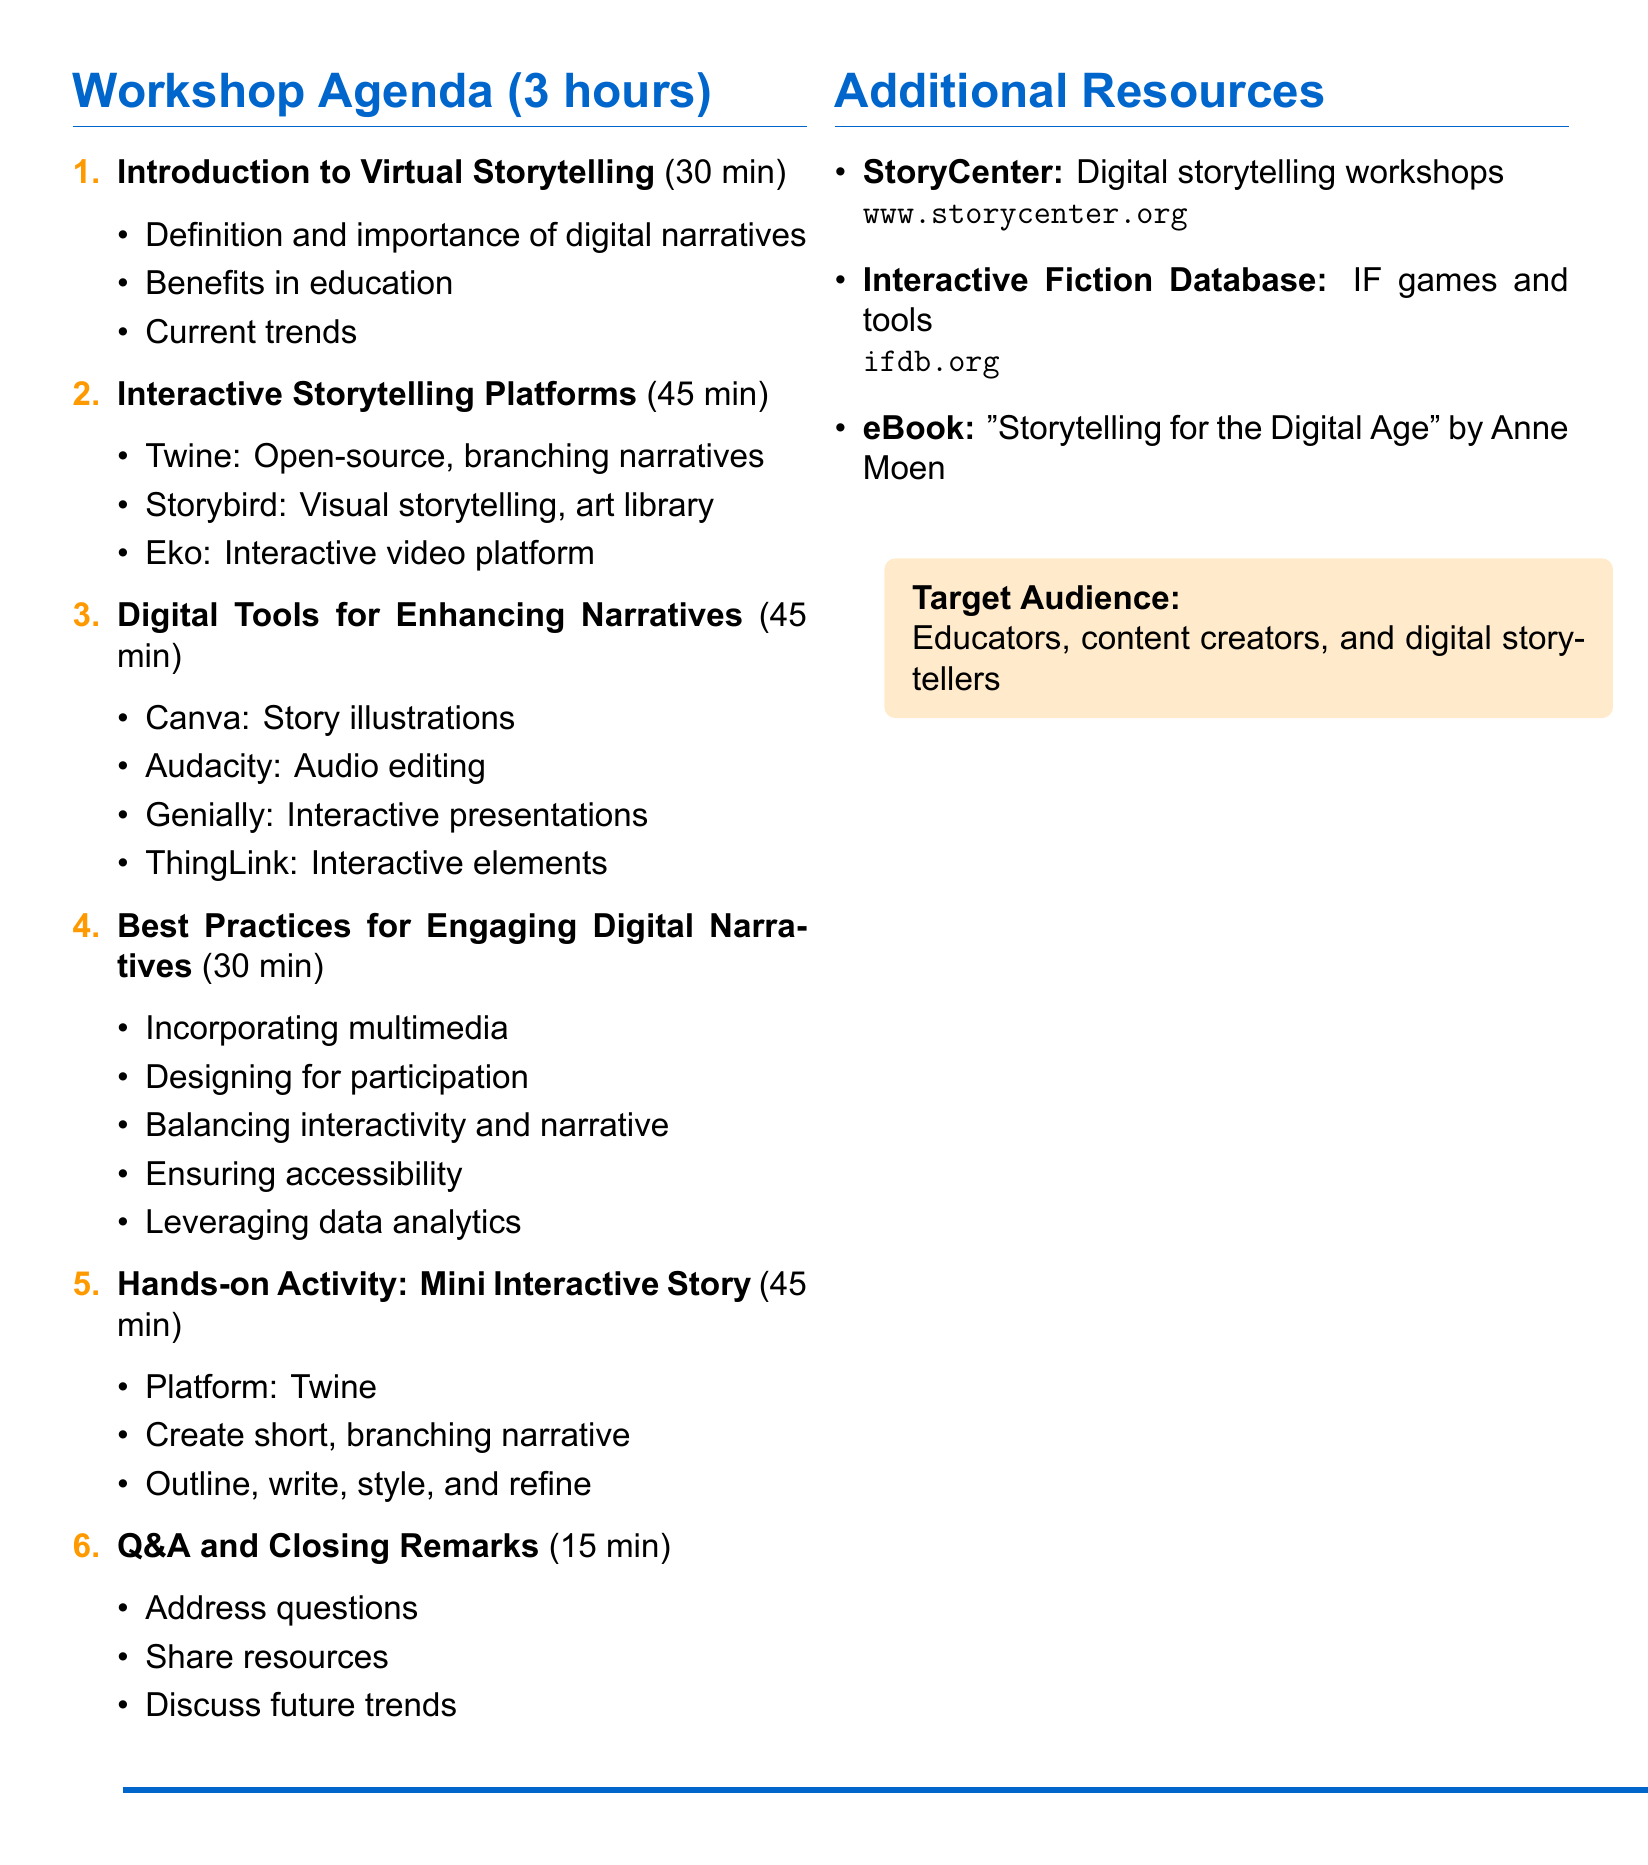What is the title of the workshop? The title of the workshop is explicitly mentioned in the document as "Virtual Storytelling Workshop: Interactive Tools and Platforms for Engaging Digital Narratives."
Answer: Virtual Storytelling Workshop: Interactive Tools and Platforms for Engaging Digital Narratives How long is the workshop? The duration of the workshop is stated as 3 hours in the document.
Answer: 3 hours Who is the target audience for the workshop? The document specifies that the target audience includes educators, content creators, and digital storytellers.
Answer: Educators, content creators, and digital storytellers What platform will be used for the hands-on activity? The hands-on activity section mentions that the platform to be used is Twine.
Answer: Twine What is one key feature of Eko? The document lists key features of Eko; one of them is "Choice-based videos."
Answer: Choice-based videos How many main sections are there in the workshop agenda? There are six main sections outlined in the workshop agenda.
Answer: 6 What is a recommended practice for engaging digital narratives? The document lists best practices; one example is "Incorporating multimedia elements."
Answer: Incorporating multimedia elements What is the duration of the Q&A and closing remarks section? The document indicates that this section lasts for 15 minutes.
Answer: 15 minutes What additional resource is provided for digital storytelling workshops? The document mentions "StoryCenter" as one additional resource for digital storytelling workshops.
Answer: StoryCenter 